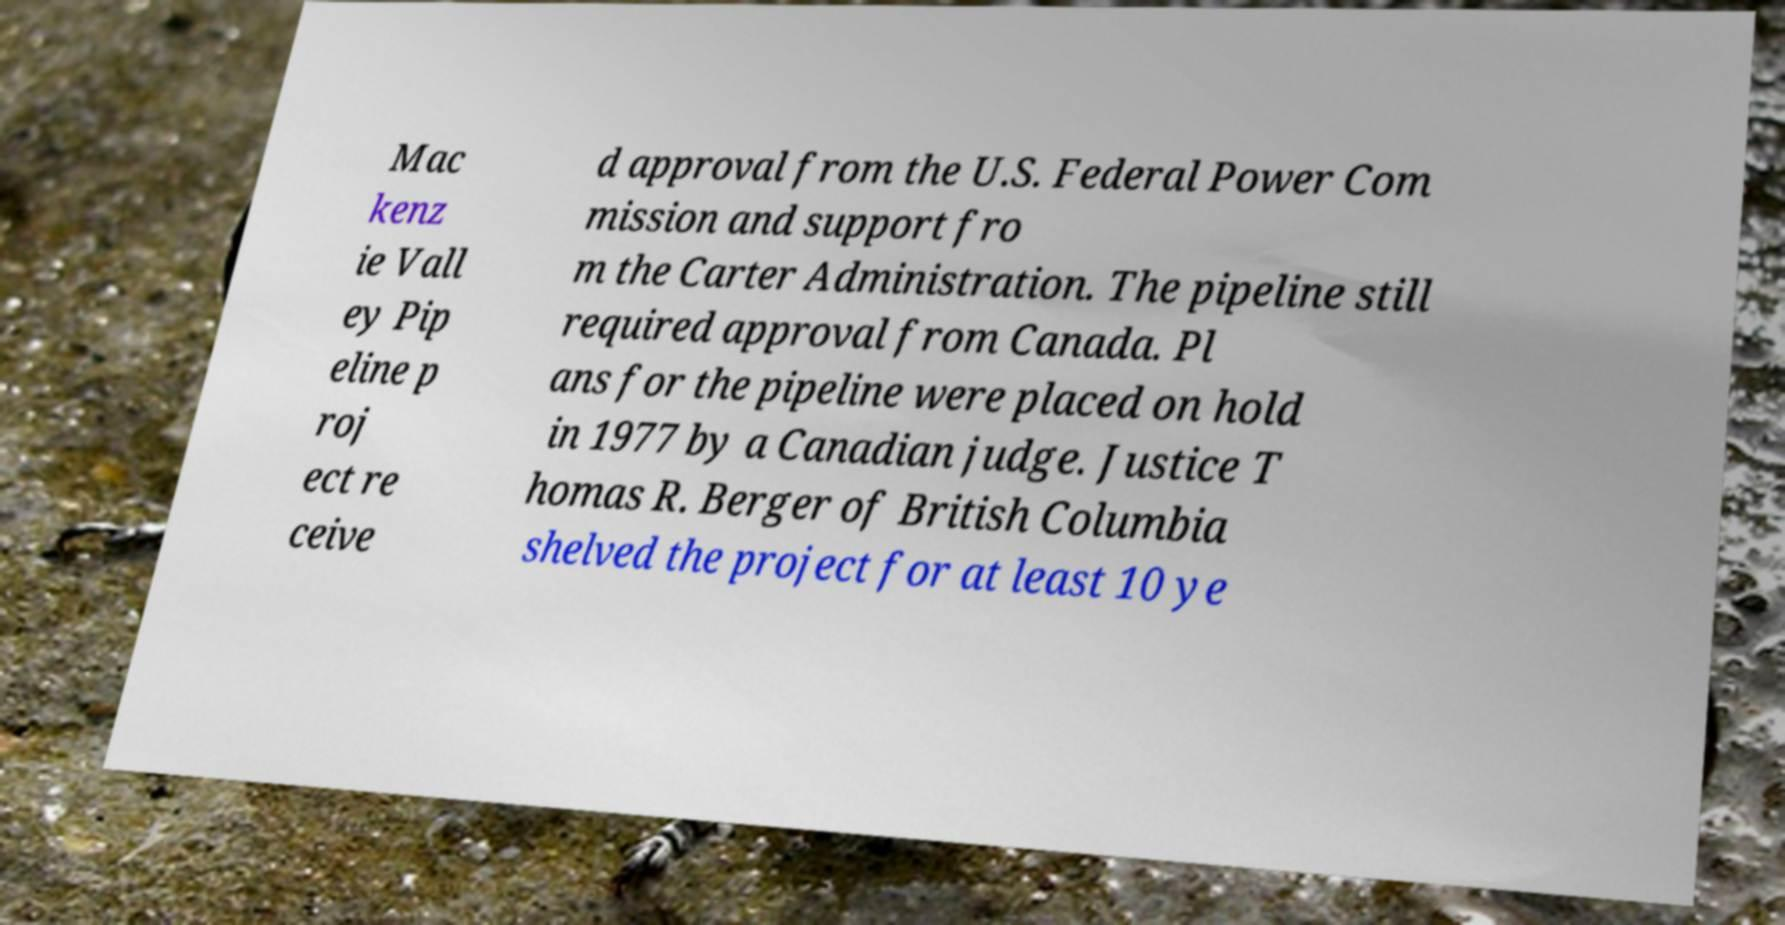Can you read and provide the text displayed in the image?This photo seems to have some interesting text. Can you extract and type it out for me? Mac kenz ie Vall ey Pip eline p roj ect re ceive d approval from the U.S. Federal Power Com mission and support fro m the Carter Administration. The pipeline still required approval from Canada. Pl ans for the pipeline were placed on hold in 1977 by a Canadian judge. Justice T homas R. Berger of British Columbia shelved the project for at least 10 ye 